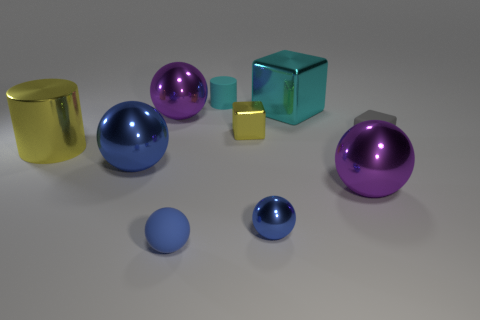How many blue spheres must be subtracted to get 1 blue spheres? 2 Subtract all blue cubes. How many purple balls are left? 2 Subtract all small blocks. How many blocks are left? 1 Subtract all purple spheres. How many spheres are left? 3 Subtract 1 balls. How many balls are left? 4 Subtract all cubes. How many objects are left? 7 Subtract all purple cylinders. Subtract all cyan spheres. How many cylinders are left? 2 Subtract 0 brown blocks. How many objects are left? 10 Subtract all cyan cylinders. Subtract all big blue spheres. How many objects are left? 8 Add 7 tiny blue rubber things. How many tiny blue rubber things are left? 8 